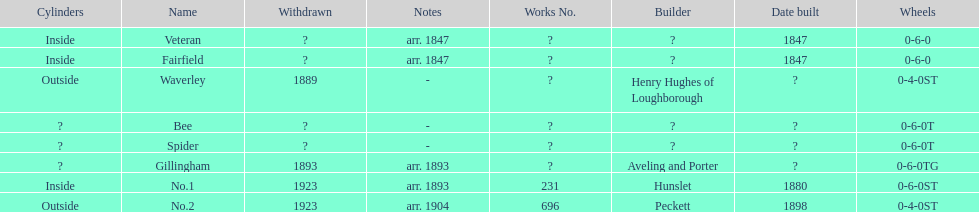Which have known built dates? Veteran, Fairfield, No.1, No.2. What other was built in 1847? Veteran. 